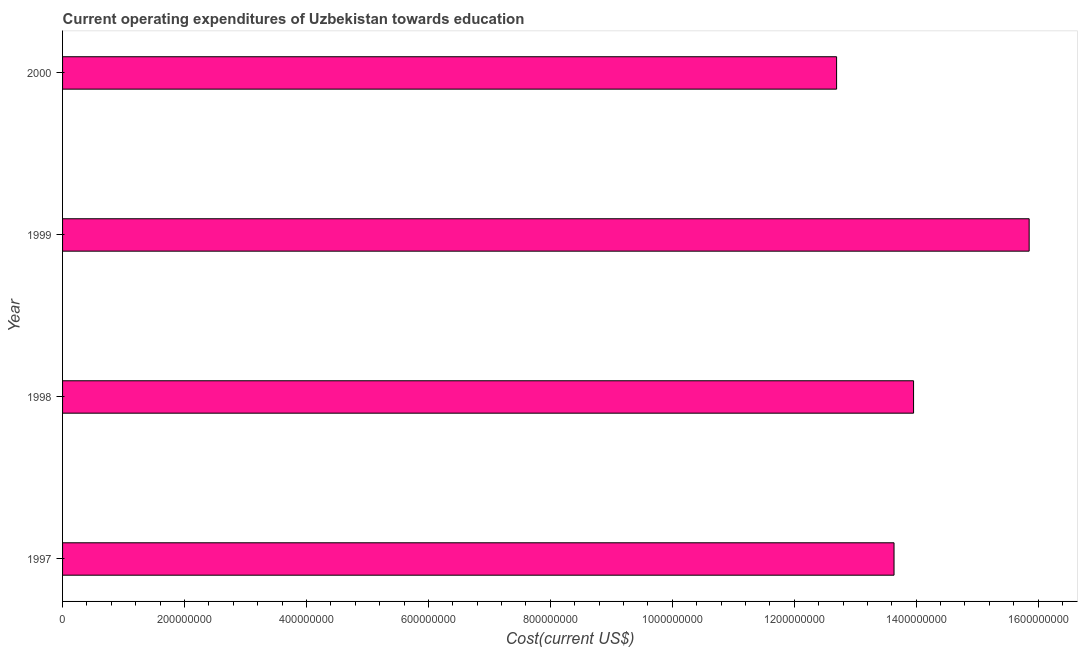What is the title of the graph?
Provide a succinct answer. Current operating expenditures of Uzbekistan towards education. What is the label or title of the X-axis?
Give a very brief answer. Cost(current US$). What is the label or title of the Y-axis?
Offer a very short reply. Year. What is the education expenditure in 1998?
Your answer should be compact. 1.40e+09. Across all years, what is the maximum education expenditure?
Your response must be concise. 1.59e+09. Across all years, what is the minimum education expenditure?
Keep it short and to the point. 1.27e+09. In which year was the education expenditure minimum?
Give a very brief answer. 2000. What is the sum of the education expenditure?
Provide a succinct answer. 5.61e+09. What is the difference between the education expenditure in 1998 and 1999?
Give a very brief answer. -1.90e+08. What is the average education expenditure per year?
Your answer should be compact. 1.40e+09. What is the median education expenditure?
Your answer should be compact. 1.38e+09. Is the education expenditure in 1999 less than that in 2000?
Provide a succinct answer. No. Is the difference between the education expenditure in 1998 and 2000 greater than the difference between any two years?
Give a very brief answer. No. What is the difference between the highest and the second highest education expenditure?
Give a very brief answer. 1.90e+08. Is the sum of the education expenditure in 1997 and 1998 greater than the maximum education expenditure across all years?
Your response must be concise. Yes. What is the difference between the highest and the lowest education expenditure?
Your answer should be very brief. 3.16e+08. In how many years, is the education expenditure greater than the average education expenditure taken over all years?
Your answer should be very brief. 1. Are all the bars in the graph horizontal?
Your answer should be very brief. Yes. What is the Cost(current US$) of 1997?
Your answer should be very brief. 1.36e+09. What is the Cost(current US$) of 1998?
Ensure brevity in your answer.  1.40e+09. What is the Cost(current US$) in 1999?
Your answer should be compact. 1.59e+09. What is the Cost(current US$) of 2000?
Provide a short and direct response. 1.27e+09. What is the difference between the Cost(current US$) in 1997 and 1998?
Make the answer very short. -3.20e+07. What is the difference between the Cost(current US$) in 1997 and 1999?
Give a very brief answer. -2.22e+08. What is the difference between the Cost(current US$) in 1997 and 2000?
Provide a succinct answer. 9.42e+07. What is the difference between the Cost(current US$) in 1998 and 1999?
Your response must be concise. -1.90e+08. What is the difference between the Cost(current US$) in 1998 and 2000?
Give a very brief answer. 1.26e+08. What is the difference between the Cost(current US$) in 1999 and 2000?
Give a very brief answer. 3.16e+08. What is the ratio of the Cost(current US$) in 1997 to that in 1998?
Provide a short and direct response. 0.98. What is the ratio of the Cost(current US$) in 1997 to that in 1999?
Your answer should be compact. 0.86. What is the ratio of the Cost(current US$) in 1997 to that in 2000?
Ensure brevity in your answer.  1.07. What is the ratio of the Cost(current US$) in 1998 to that in 2000?
Your answer should be very brief. 1.1. What is the ratio of the Cost(current US$) in 1999 to that in 2000?
Provide a succinct answer. 1.25. 